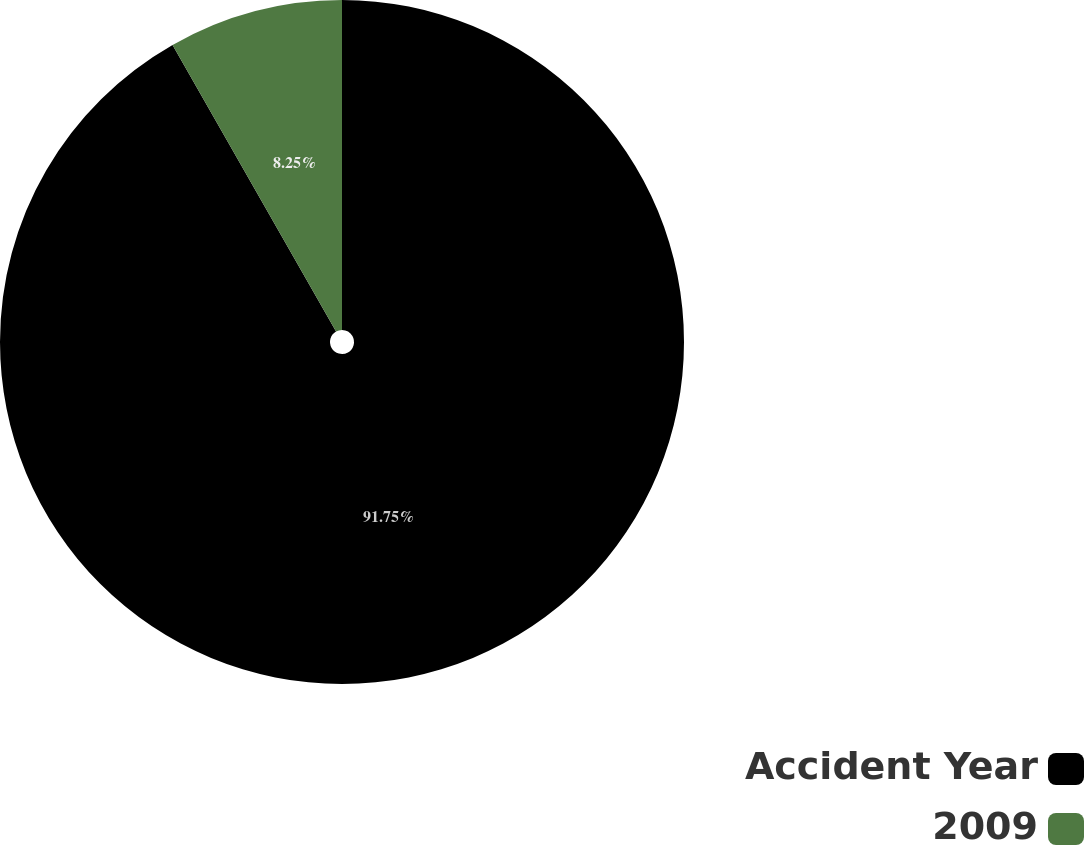Convert chart. <chart><loc_0><loc_0><loc_500><loc_500><pie_chart><fcel>Accident Year<fcel>2009<nl><fcel>91.75%<fcel>8.25%<nl></chart> 